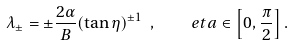Convert formula to latex. <formula><loc_0><loc_0><loc_500><loc_500>\lambda _ { \pm } = \pm \frac { 2 \alpha } { B } ( \tan \eta ) ^ { \pm 1 } \ , \quad e t a \in \left [ 0 , \frac { \pi } { 2 } \right ] .</formula> 